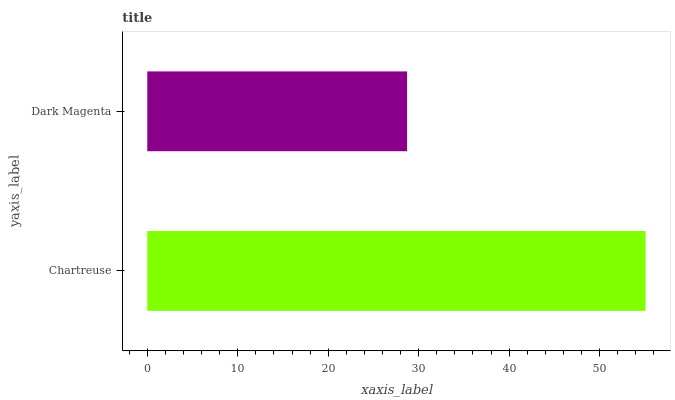Is Dark Magenta the minimum?
Answer yes or no. Yes. Is Chartreuse the maximum?
Answer yes or no. Yes. Is Dark Magenta the maximum?
Answer yes or no. No. Is Chartreuse greater than Dark Magenta?
Answer yes or no. Yes. Is Dark Magenta less than Chartreuse?
Answer yes or no. Yes. Is Dark Magenta greater than Chartreuse?
Answer yes or no. No. Is Chartreuse less than Dark Magenta?
Answer yes or no. No. Is Chartreuse the high median?
Answer yes or no. Yes. Is Dark Magenta the low median?
Answer yes or no. Yes. Is Dark Magenta the high median?
Answer yes or no. No. Is Chartreuse the low median?
Answer yes or no. No. 